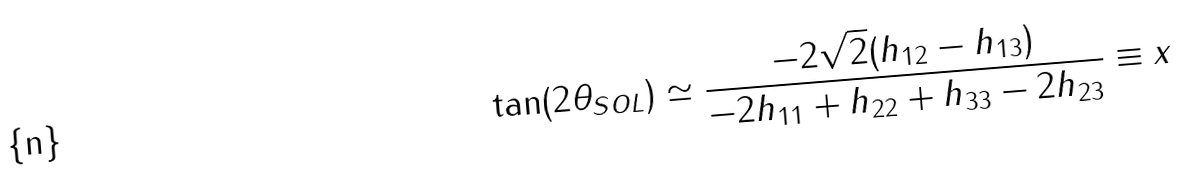Convert formula to latex. <formula><loc_0><loc_0><loc_500><loc_500>\tan ( 2 \theta _ { S O L } ) \simeq \frac { - 2 \sqrt { 2 } ( h _ { 1 2 } - h _ { 1 3 } ) } { - 2 h _ { 1 1 } + h _ { 2 2 } + h _ { 3 3 } - 2 h _ { 2 3 } } \equiv x</formula> 